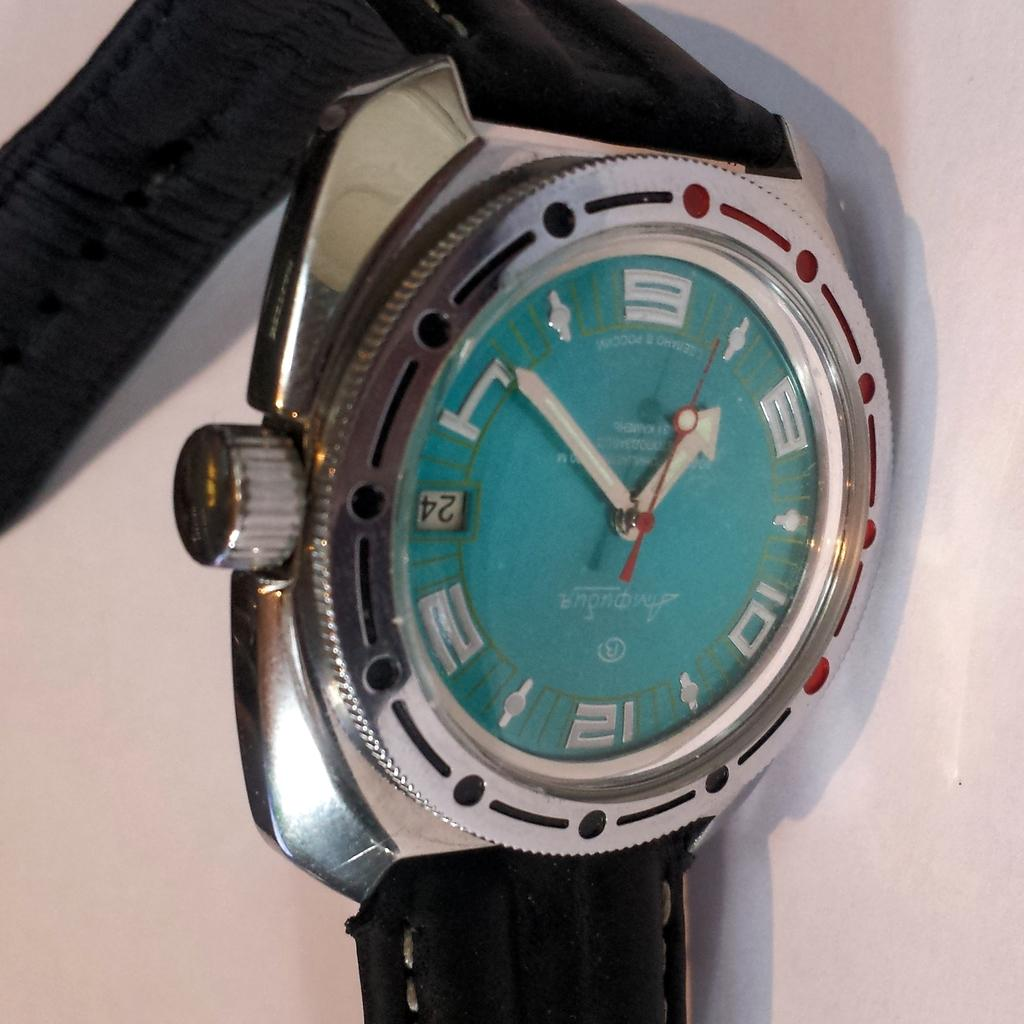<image>
Render a clear and concise summary of the photo. A watch with a bright blue face shows that the date is the 24th. 